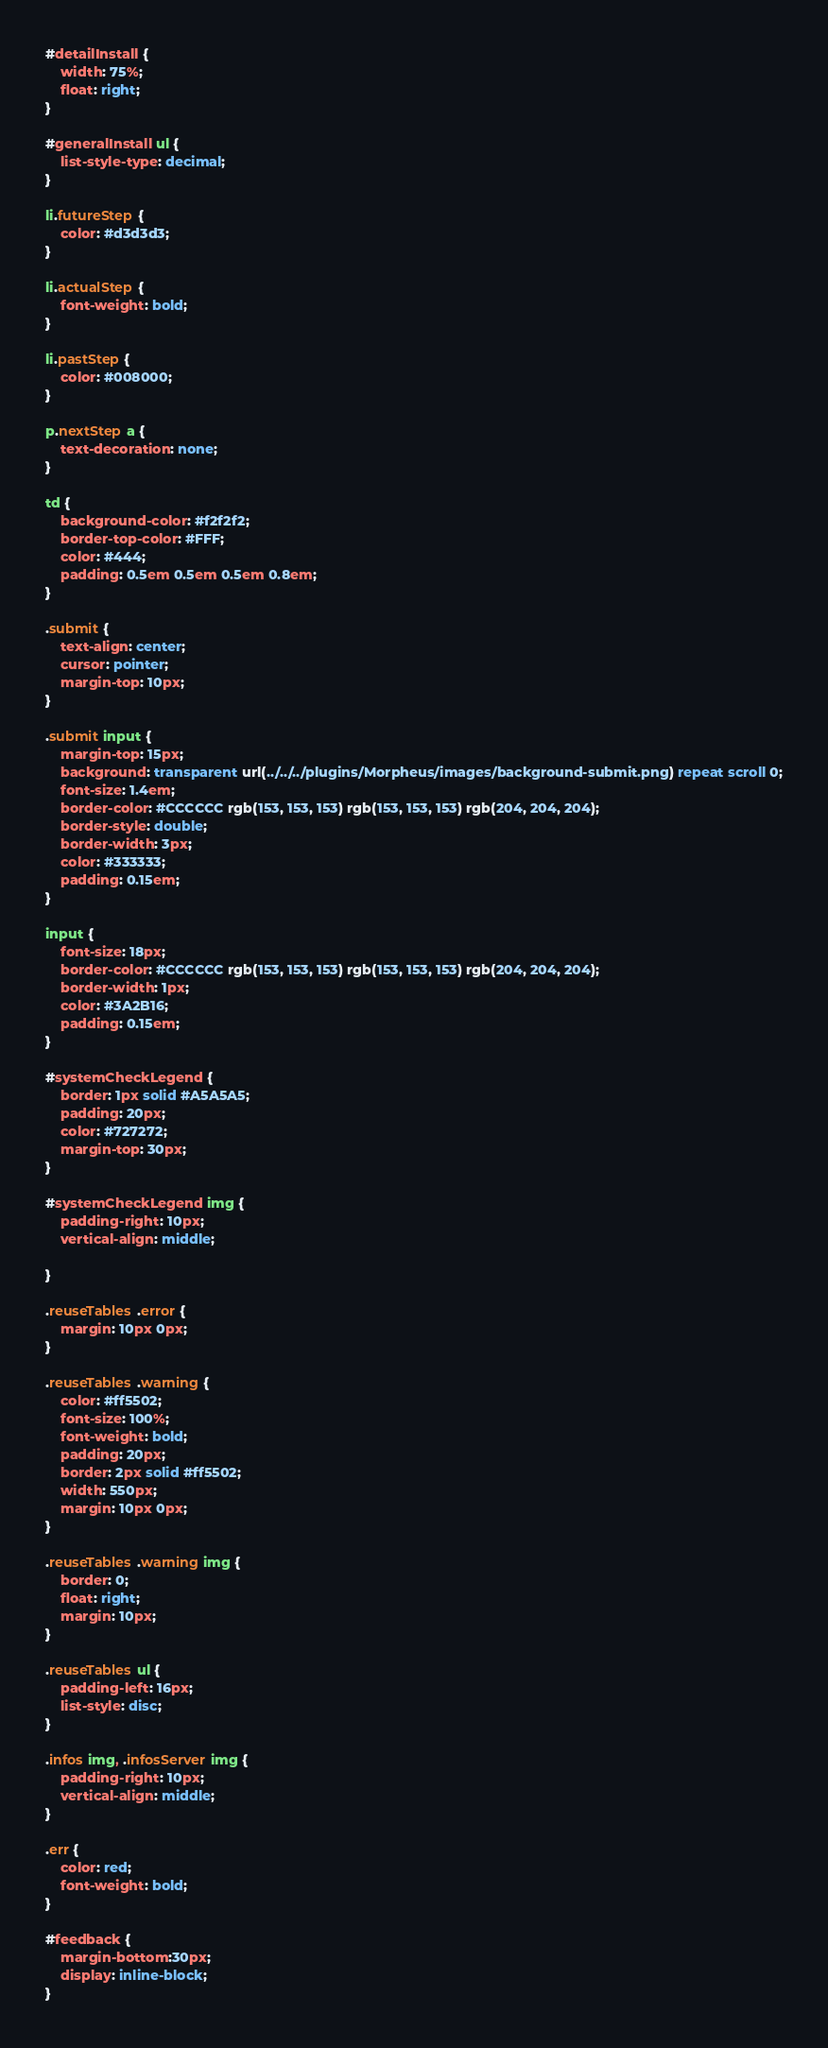<code> <loc_0><loc_0><loc_500><loc_500><_CSS_>#detailInstall {
    width: 75%;
    float: right;
}

#generalInstall ul {
    list-style-type: decimal;
}

li.futureStep {
    color: #d3d3d3;
}

li.actualStep {
    font-weight: bold;
}

li.pastStep {
    color: #008000;
}

p.nextStep a {
    text-decoration: none;
}

td {
    background-color: #f2f2f2;
    border-top-color: #FFF;
    color: #444;
    padding: 0.5em 0.5em 0.5em 0.8em;
}

.submit {
    text-align: center;
    cursor: pointer;
    margin-top: 10px;
}

.submit input {
    margin-top: 15px;
    background: transparent url(../../../plugins/Morpheus/images/background-submit.png) repeat scroll 0;
    font-size: 1.4em;
    border-color: #CCCCCC rgb(153, 153, 153) rgb(153, 153, 153) rgb(204, 204, 204);
    border-style: double;
    border-width: 3px;
    color: #333333;
    padding: 0.15em;
}

input {
    font-size: 18px;
    border-color: #CCCCCC rgb(153, 153, 153) rgb(153, 153, 153) rgb(204, 204, 204);
    border-width: 1px;
    color: #3A2B16;
    padding: 0.15em;
}

#systemCheckLegend {
    border: 1px solid #A5A5A5;
    padding: 20px;
    color: #727272;
    margin-top: 30px;
}

#systemCheckLegend img {
    padding-right: 10px;
    vertical-align: middle;

}

.reuseTables .error {
    margin: 10px 0px;
}

.reuseTables .warning {
    color: #ff5502;
    font-size: 100%;
    font-weight: bold;
    padding: 20px;
    border: 2px solid #ff5502;
    width: 550px;
    margin: 10px 0px;
}

.reuseTables .warning img {
    border: 0;
    float: right;
    margin: 10px;
}

.reuseTables ul {
    padding-left: 16px;
    list-style: disc;
}

.infos img, .infosServer img {
    padding-right: 10px;
    vertical-align: middle;
}

.err {
    color: red;
    font-weight: bold;
}

#feedback {
    margin-bottom:30px;
    display: inline-block;
}</code> 